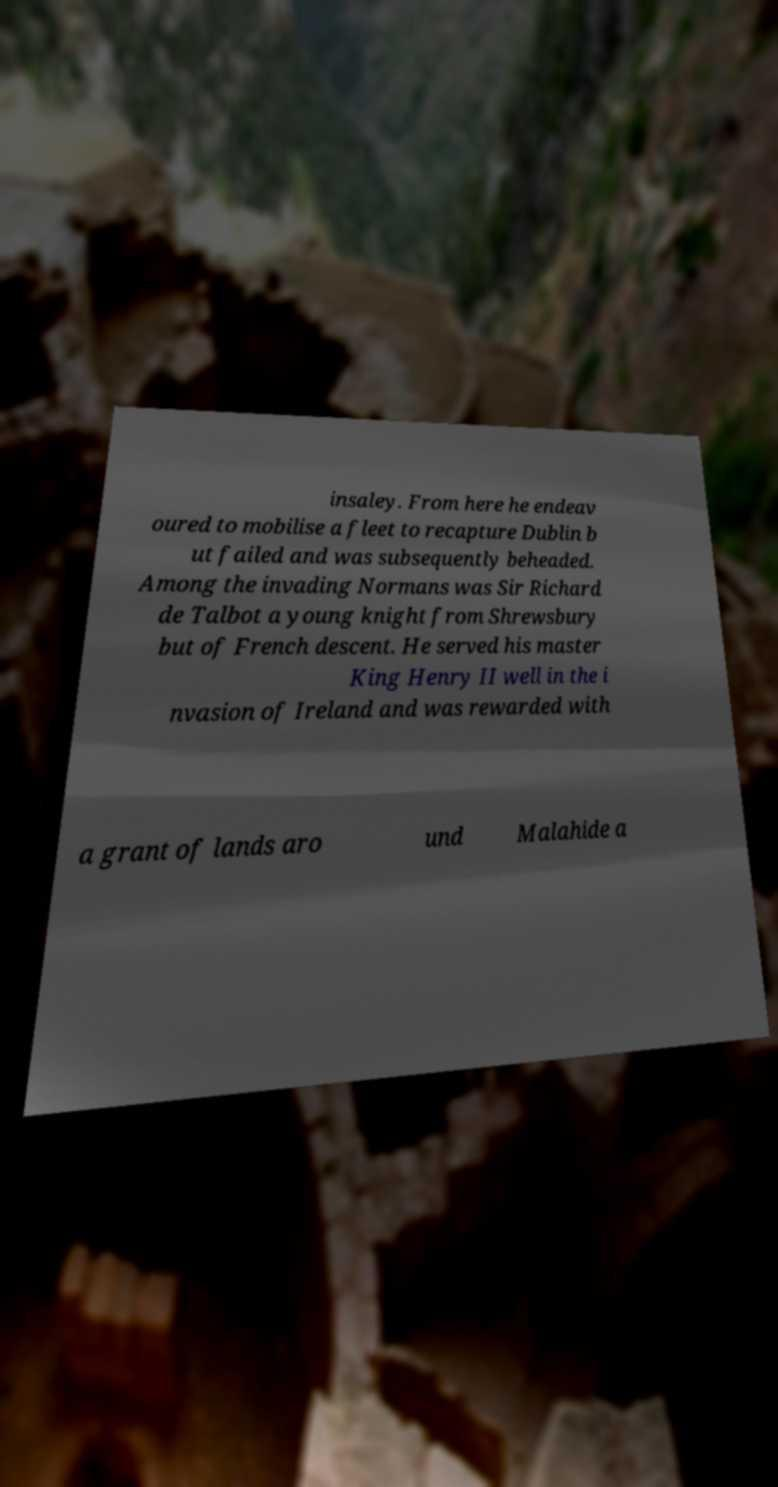Please read and relay the text visible in this image. What does it say? insaley. From here he endeav oured to mobilise a fleet to recapture Dublin b ut failed and was subsequently beheaded. Among the invading Normans was Sir Richard de Talbot a young knight from Shrewsbury but of French descent. He served his master King Henry II well in the i nvasion of Ireland and was rewarded with a grant of lands aro und Malahide a 